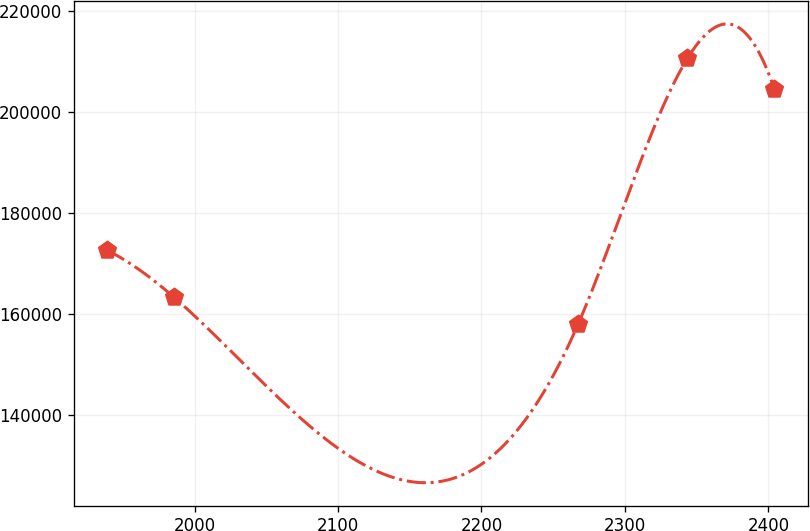<chart> <loc_0><loc_0><loc_500><loc_500><line_chart><ecel><fcel>Unnamed: 1<nl><fcel>1939.17<fcel>172547<nl><fcel>1985.67<fcel>163272<nl><fcel>2267.52<fcel>158016<nl><fcel>2343.64<fcel>210582<nl><fcel>2404.13<fcel>204562<nl></chart> 